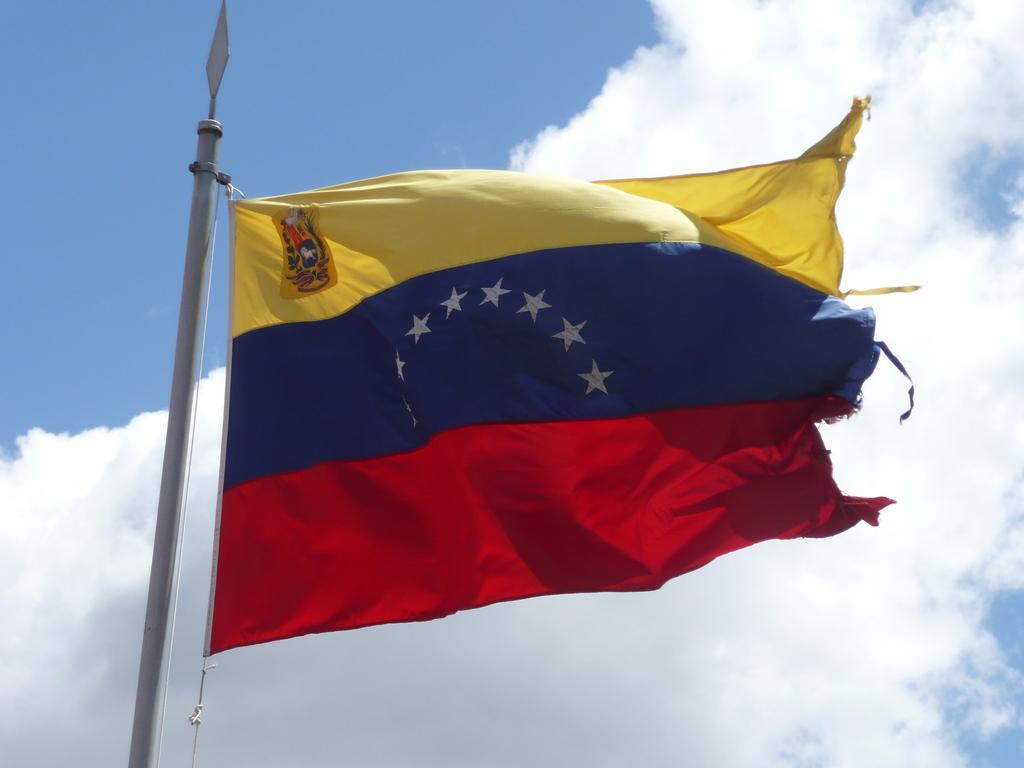Can you describe this image briefly? Here I can see a flag to a pole. The flag is in yellow, blue and red colors. In the background, I can see the sky and clouds. 